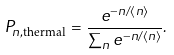Convert formula to latex. <formula><loc_0><loc_0><loc_500><loc_500>P _ { n , \text {thermal} } = \frac { e ^ { - n / \langle n \rangle } } { \sum _ { n } e ^ { - n / \langle n \rangle } } .</formula> 